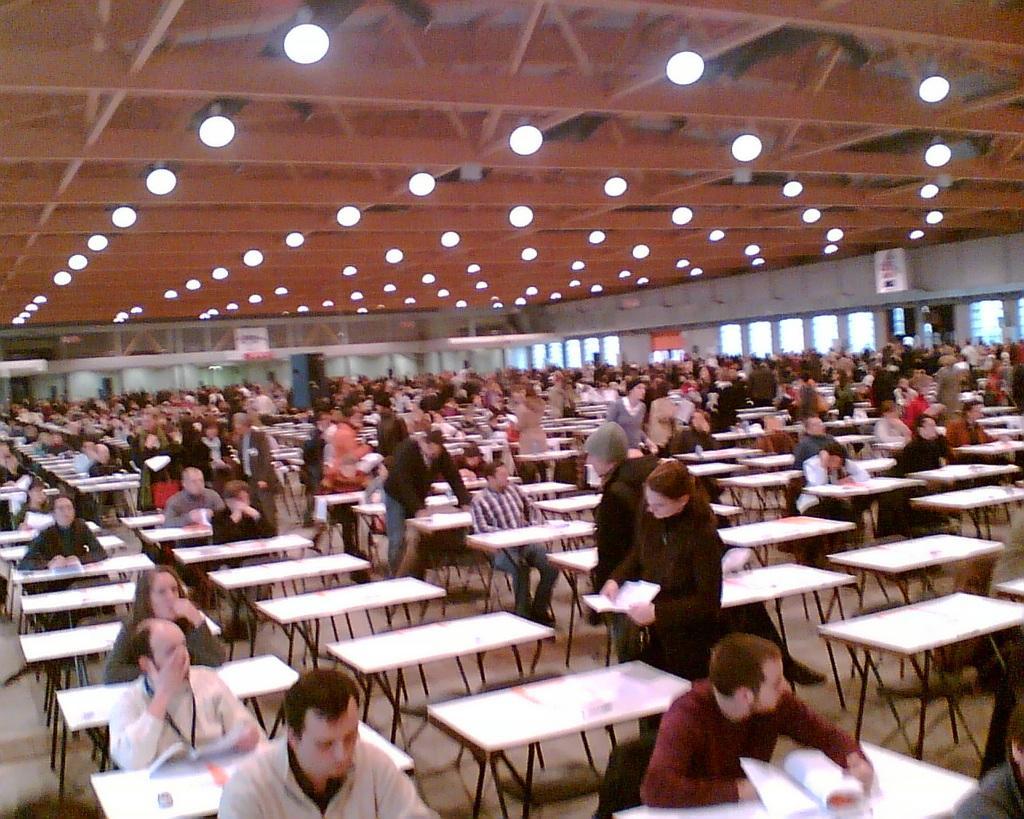In one or two sentences, can you explain what this image depicts? In the image few people are sitting and standing near to the tables. Top of the image there is a roof and lights. 